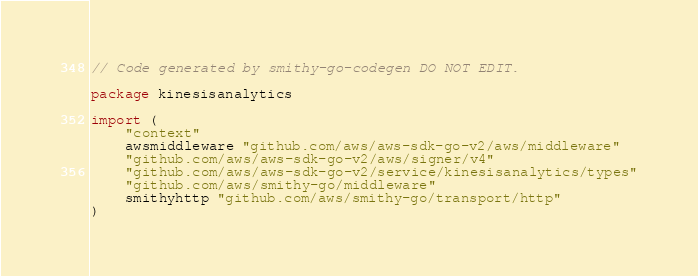<code> <loc_0><loc_0><loc_500><loc_500><_Go_>// Code generated by smithy-go-codegen DO NOT EDIT.

package kinesisanalytics

import (
	"context"
	awsmiddleware "github.com/aws/aws-sdk-go-v2/aws/middleware"
	"github.com/aws/aws-sdk-go-v2/aws/signer/v4"
	"github.com/aws/aws-sdk-go-v2/service/kinesisanalytics/types"
	"github.com/aws/smithy-go/middleware"
	smithyhttp "github.com/aws/smithy-go/transport/http"
)
</code> 